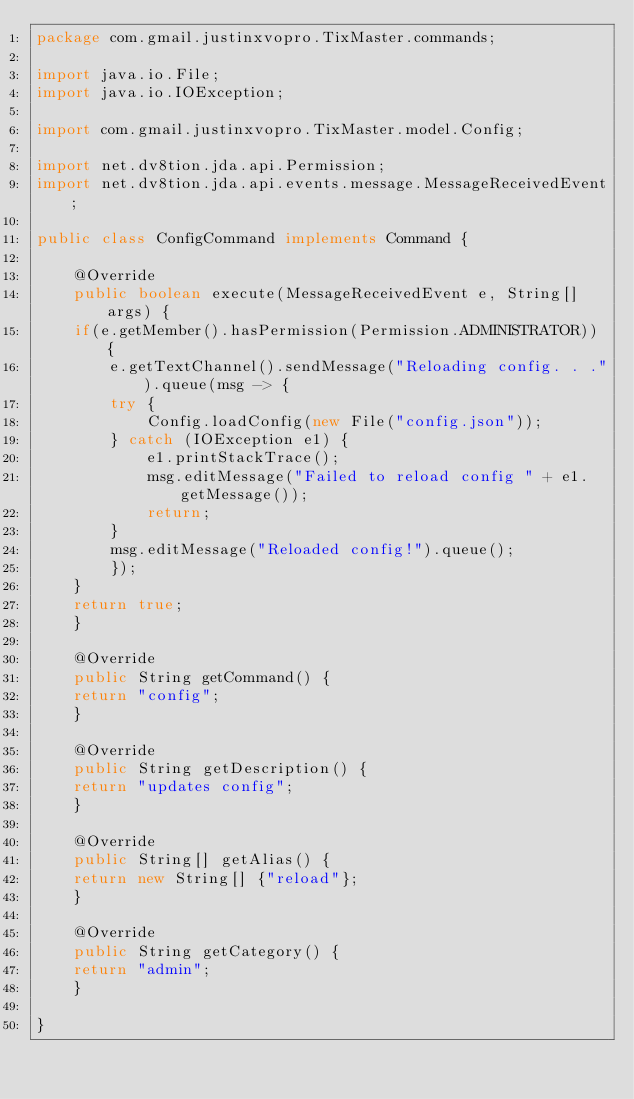<code> <loc_0><loc_0><loc_500><loc_500><_Java_>package com.gmail.justinxvopro.TixMaster.commands;

import java.io.File;
import java.io.IOException;

import com.gmail.justinxvopro.TixMaster.model.Config;

import net.dv8tion.jda.api.Permission;
import net.dv8tion.jda.api.events.message.MessageReceivedEvent;

public class ConfigCommand implements Command {

    @Override
    public boolean execute(MessageReceivedEvent e, String[] args) {
	if(e.getMember().hasPermission(Permission.ADMINISTRATOR)) {
	    e.getTextChannel().sendMessage("Reloading config. . .").queue(msg -> {
		try {
		    Config.loadConfig(new File("config.json"));
		} catch (IOException e1) {
		    e1.printStackTrace();
		    msg.editMessage("Failed to reload config " + e1.getMessage());
		    return;
		}
		msg.editMessage("Reloaded config!").queue();
	    });
	}
	return true;
    }

    @Override
    public String getCommand() {
	return "config";
    }

    @Override
    public String getDescription() {
	return "updates config";
    }

    @Override
    public String[] getAlias() {
	return new String[] {"reload"};
    }

    @Override
    public String getCategory() {
	return "admin";
    }

}
</code> 